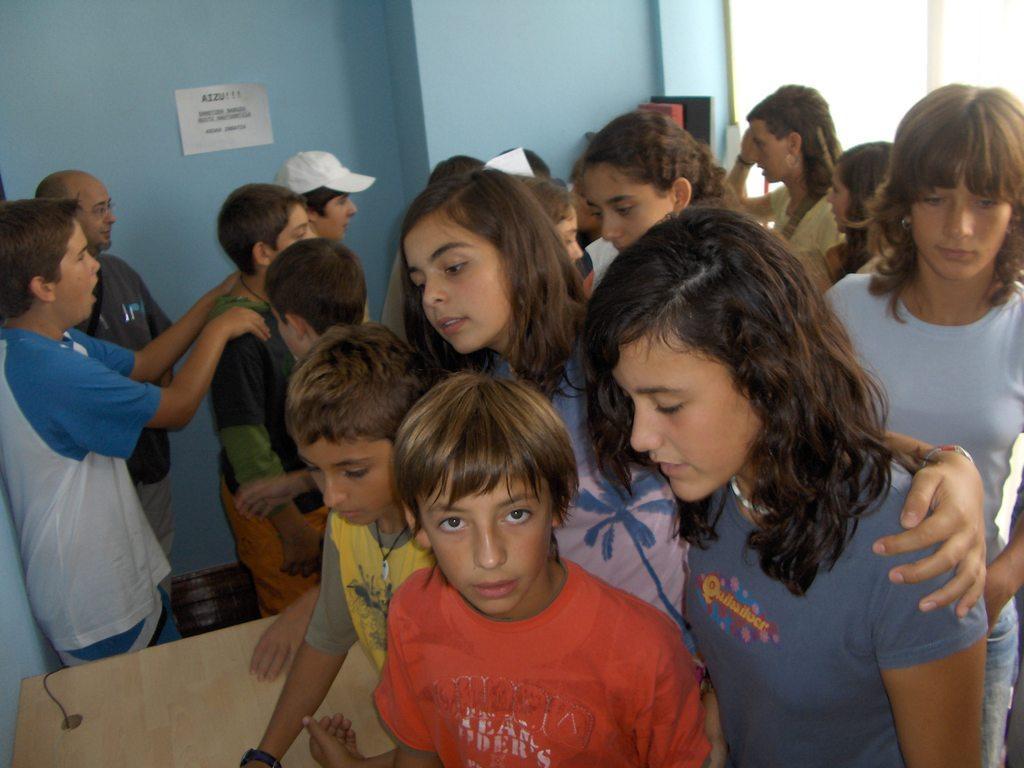Describe this image in one or two sentences. In this picture I can see group of people standing, there is a table, there are some objects, and in the background there is a paper on the wall. 